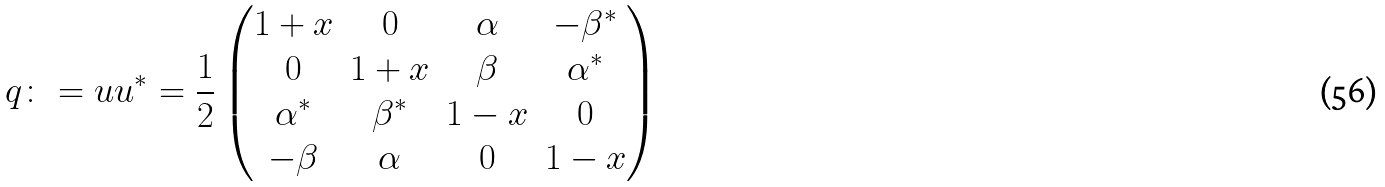Convert formula to latex. <formula><loc_0><loc_0><loc_500><loc_500>q \colon = u u ^ { * } = \frac { 1 } { 2 } \begin{pmatrix} 1 + x & 0 & \alpha & - \beta ^ { * } \\ 0 & 1 + x & \beta & \alpha ^ { * } \\ \alpha ^ { * } & \beta ^ { * } & 1 - x & 0 \\ - \beta & \alpha & 0 & 1 - x \end{pmatrix}</formula> 